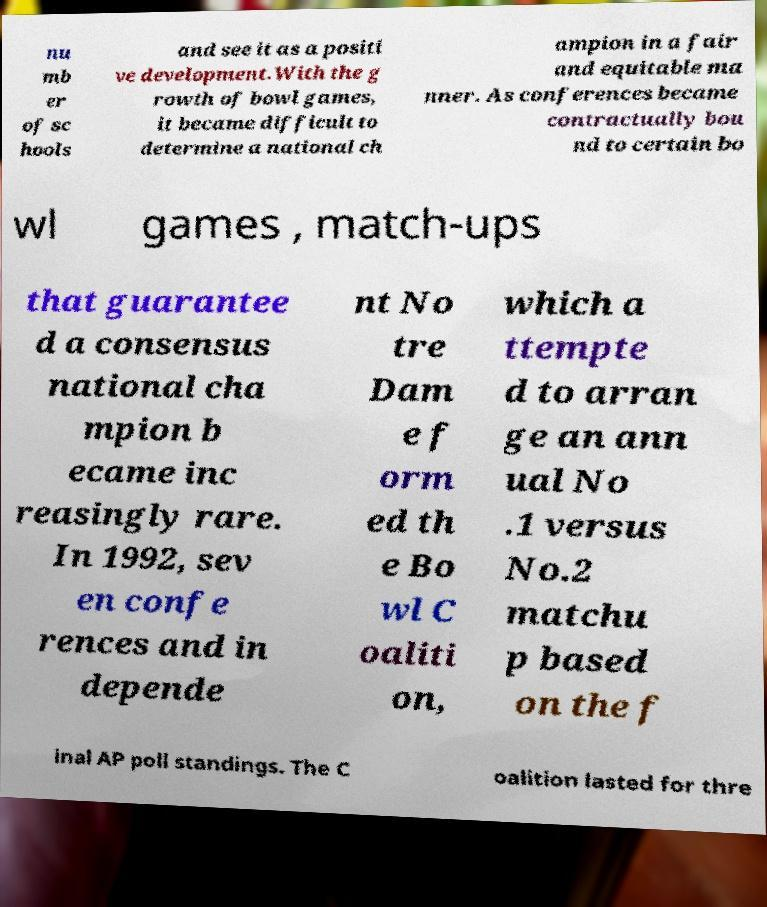Please read and relay the text visible in this image. What does it say? nu mb er of sc hools and see it as a positi ve development.With the g rowth of bowl games, it became difficult to determine a national ch ampion in a fair and equitable ma nner. As conferences became contractually bou nd to certain bo wl games , match-ups that guarantee d a consensus national cha mpion b ecame inc reasingly rare. In 1992, sev en confe rences and in depende nt No tre Dam e f orm ed th e Bo wl C oaliti on, which a ttempte d to arran ge an ann ual No .1 versus No.2 matchu p based on the f inal AP poll standings. The C oalition lasted for thre 